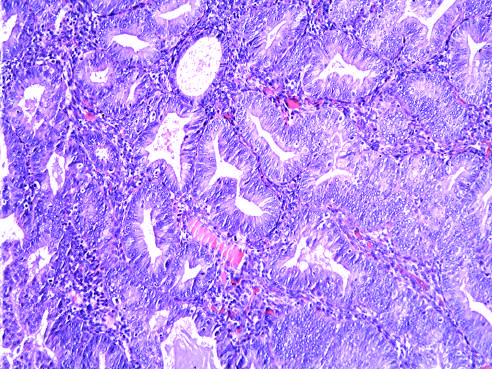s hyperplasia with atypia seen as glandular crowding and cellular atypia?
Answer the question using a single word or phrase. Yes 